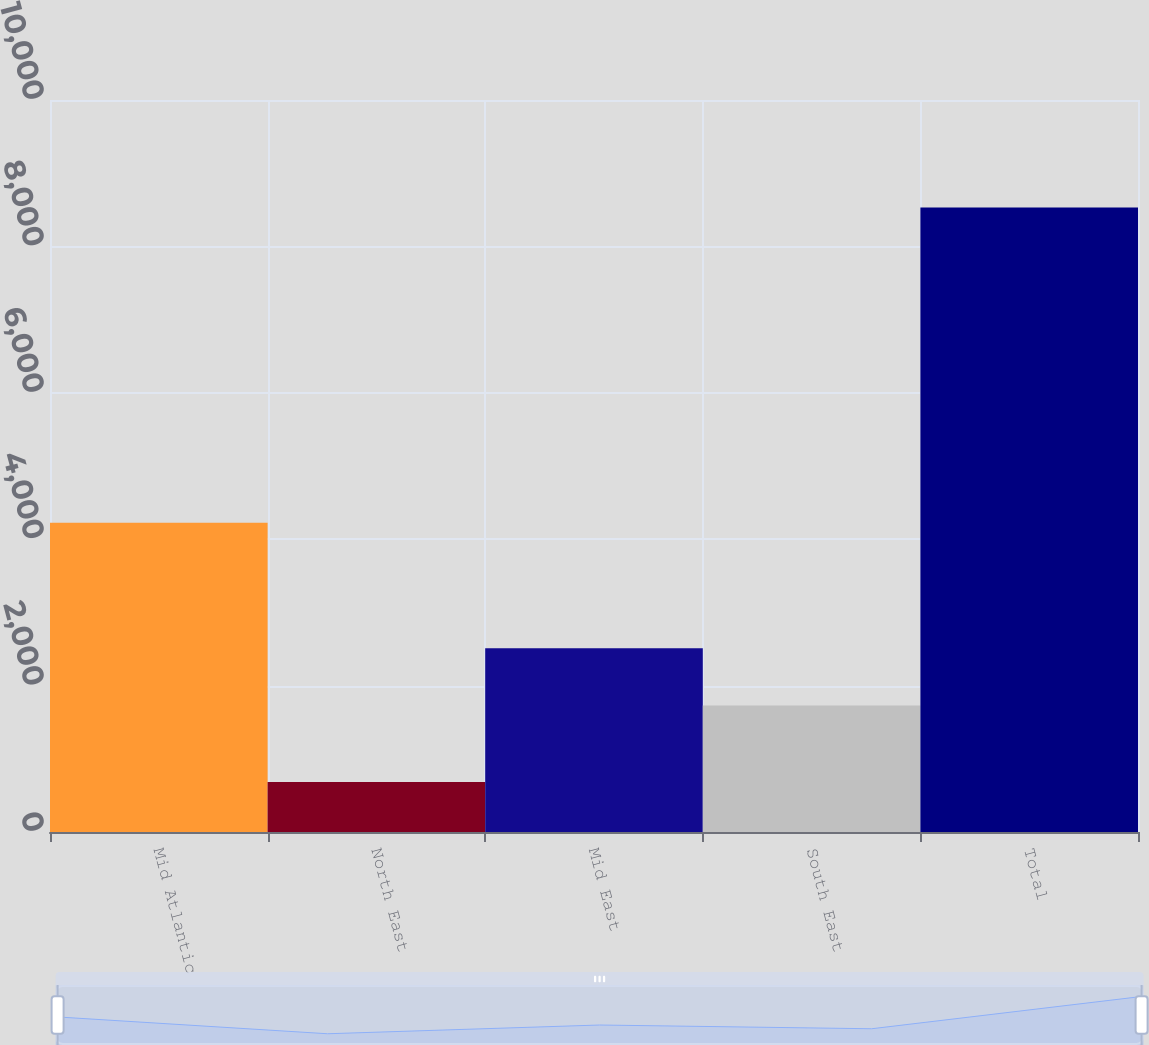Convert chart. <chart><loc_0><loc_0><loc_500><loc_500><bar_chart><fcel>Mid Atlantic<fcel>North East<fcel>Mid East<fcel>South East<fcel>Total<nl><fcel>4224<fcel>682<fcel>2511.9<fcel>1727<fcel>8531<nl></chart> 